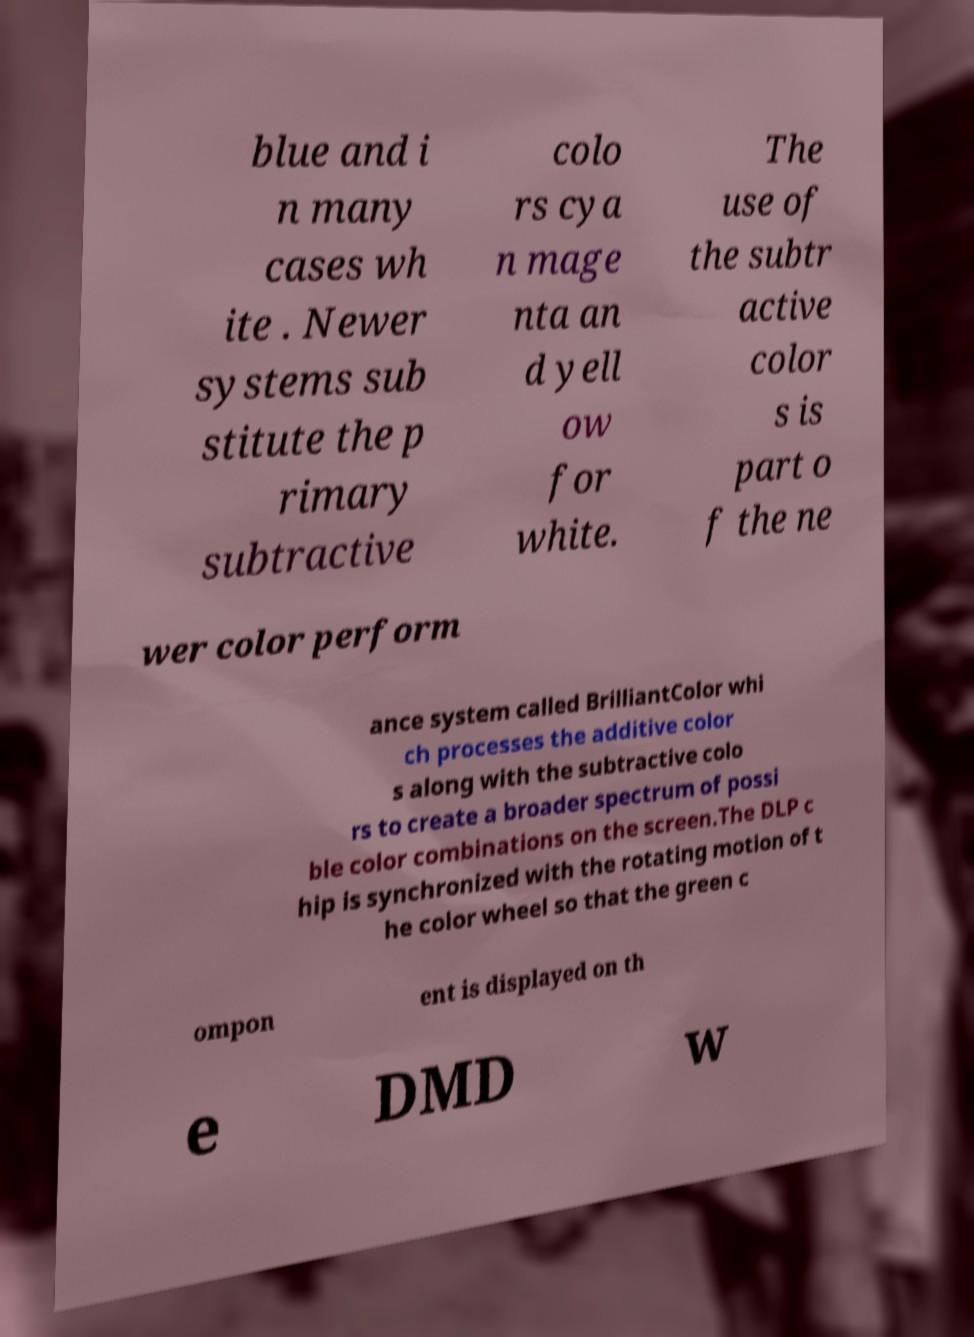For documentation purposes, I need the text within this image transcribed. Could you provide that? blue and i n many cases wh ite . Newer systems sub stitute the p rimary subtractive colo rs cya n mage nta an d yell ow for white. The use of the subtr active color s is part o f the ne wer color perform ance system called BrilliantColor whi ch processes the additive color s along with the subtractive colo rs to create a broader spectrum of possi ble color combinations on the screen.The DLP c hip is synchronized with the rotating motion of t he color wheel so that the green c ompon ent is displayed on th e DMD w 